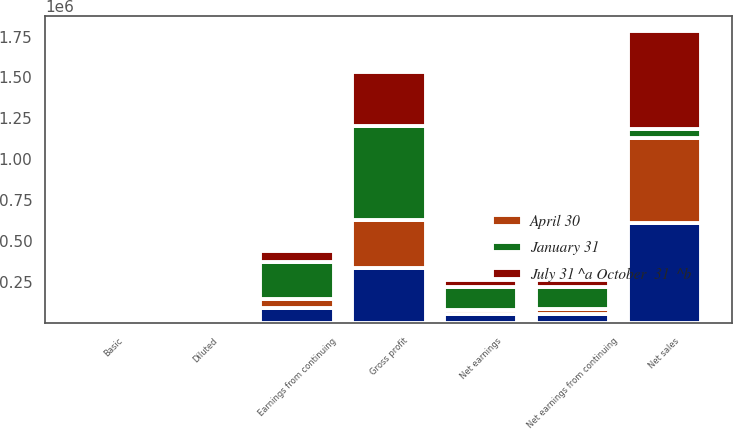Convert chart to OTSL. <chart><loc_0><loc_0><loc_500><loc_500><stacked_bar_chart><ecel><fcel>Net sales<fcel>Gross profit<fcel>Earnings from continuing<fcel>Net earnings from continuing<fcel>Net earnings<fcel>Basic<fcel>Diluted<nl><fcel>April 30<fcel>517615<fcel>289219<fcel>59514<fcel>27443<fcel>24341<fcel>0.22<fcel>0.22<nl><fcel>nan<fcel>612493<fcel>337452<fcel>89554<fcel>56717<fcel>56776<fcel>0.46<fcel>0.46<nl><fcel>July 31 ^a October  31  ^b<fcel>598212<fcel>327803<fcel>66817<fcel>43309<fcel>43339<fcel>0.35<fcel>0.34<nl><fcel>January 31<fcel>56776<fcel>575745<fcel>224607<fcel>138207<fcel>140367<fcel>1.1<fcel>1.09<nl></chart> 